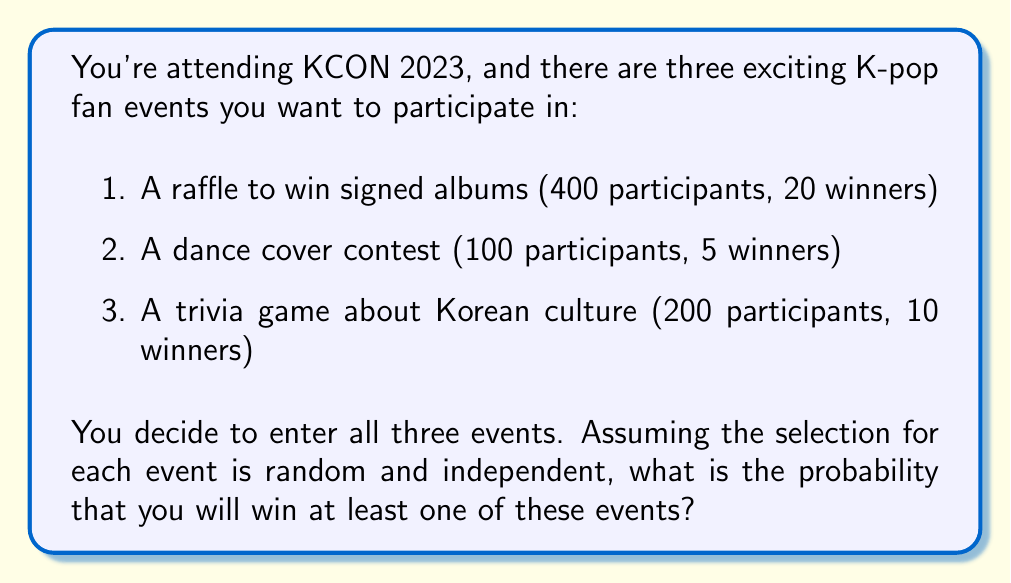Solve this math problem. Let's approach this step-by-step using the concept of probability of complementary events.

1) First, let's calculate the probability of winning each event:

   Raffle: $P(\text{Raffle}) = \frac{20}{400} = \frac{1}{20} = 0.05$
   Dance contest: $P(\text{Dance}) = \frac{5}{100} = \frac{1}{20} = 0.05$
   Trivia game: $P(\text{Trivia}) = \frac{10}{200} = \frac{1}{20} = 0.05$

2) Now, let's calculate the probability of not winning each event:

   $P(\text{Not Raffle}) = 1 - 0.05 = 0.95$
   $P(\text{Not Dance}) = 1 - 0.05 = 0.95$
   $P(\text{Not Trivia}) = 1 - 0.05 = 0.95$

3) The probability of not winning any event is the product of the probabilities of not winning each individual event:

   $P(\text{No Win}) = 0.95 \times 0.95 \times 0.95 = 0.857375$

4) The probability of winning at least one event is the complement of not winning any event:

   $P(\text{At Least One Win}) = 1 - P(\text{No Win})$
   $= 1 - 0.857375$
   $= 0.142625$

Therefore, the probability of winning at least one event is approximately 0.142625 or 14.2625%.
Answer: The probability of winning at least one of the three K-pop fan events is approximately 0.142625 or 14.2625%. 